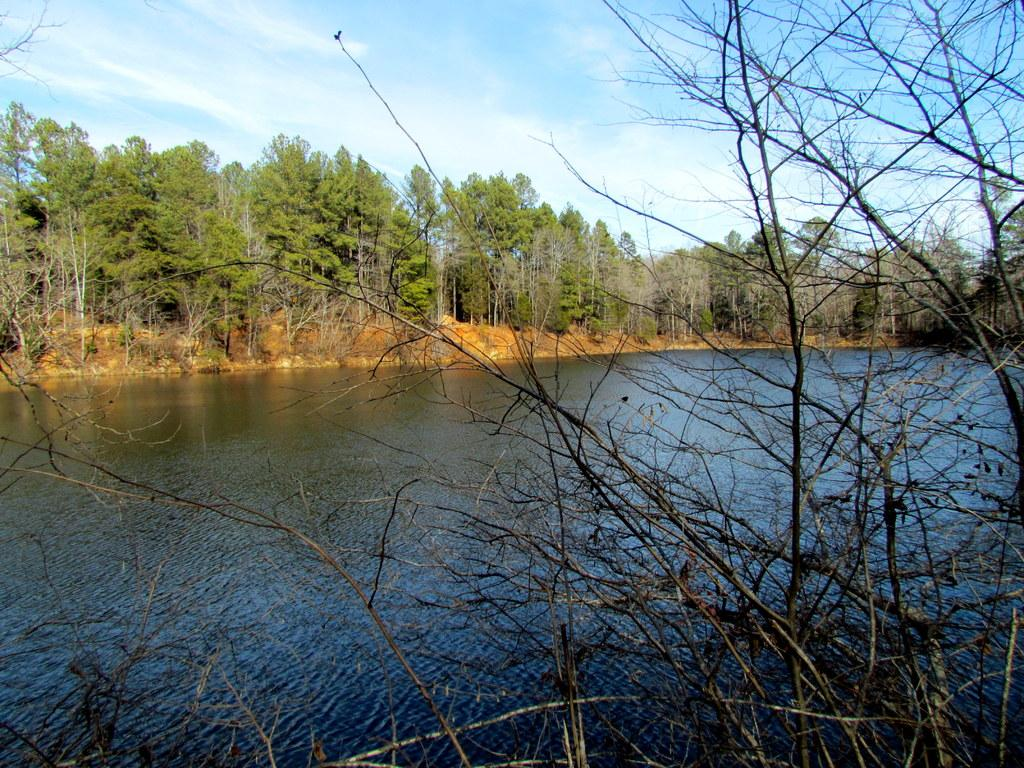What type of view is shown in the image? The image is an outside view. What natural features can be seen in the image? There are trees beside the lake in the image. What is visible on the right side of the image? There are branches on the right side of the image. What is visible at the top of the image? The sky is visible at the top of the image. What type of roof can be seen on the lake in the image? There is no roof present on the lake in the image. What color is the grass on the left side of the image? There is no grass visible in the image; it features a lake and trees. 